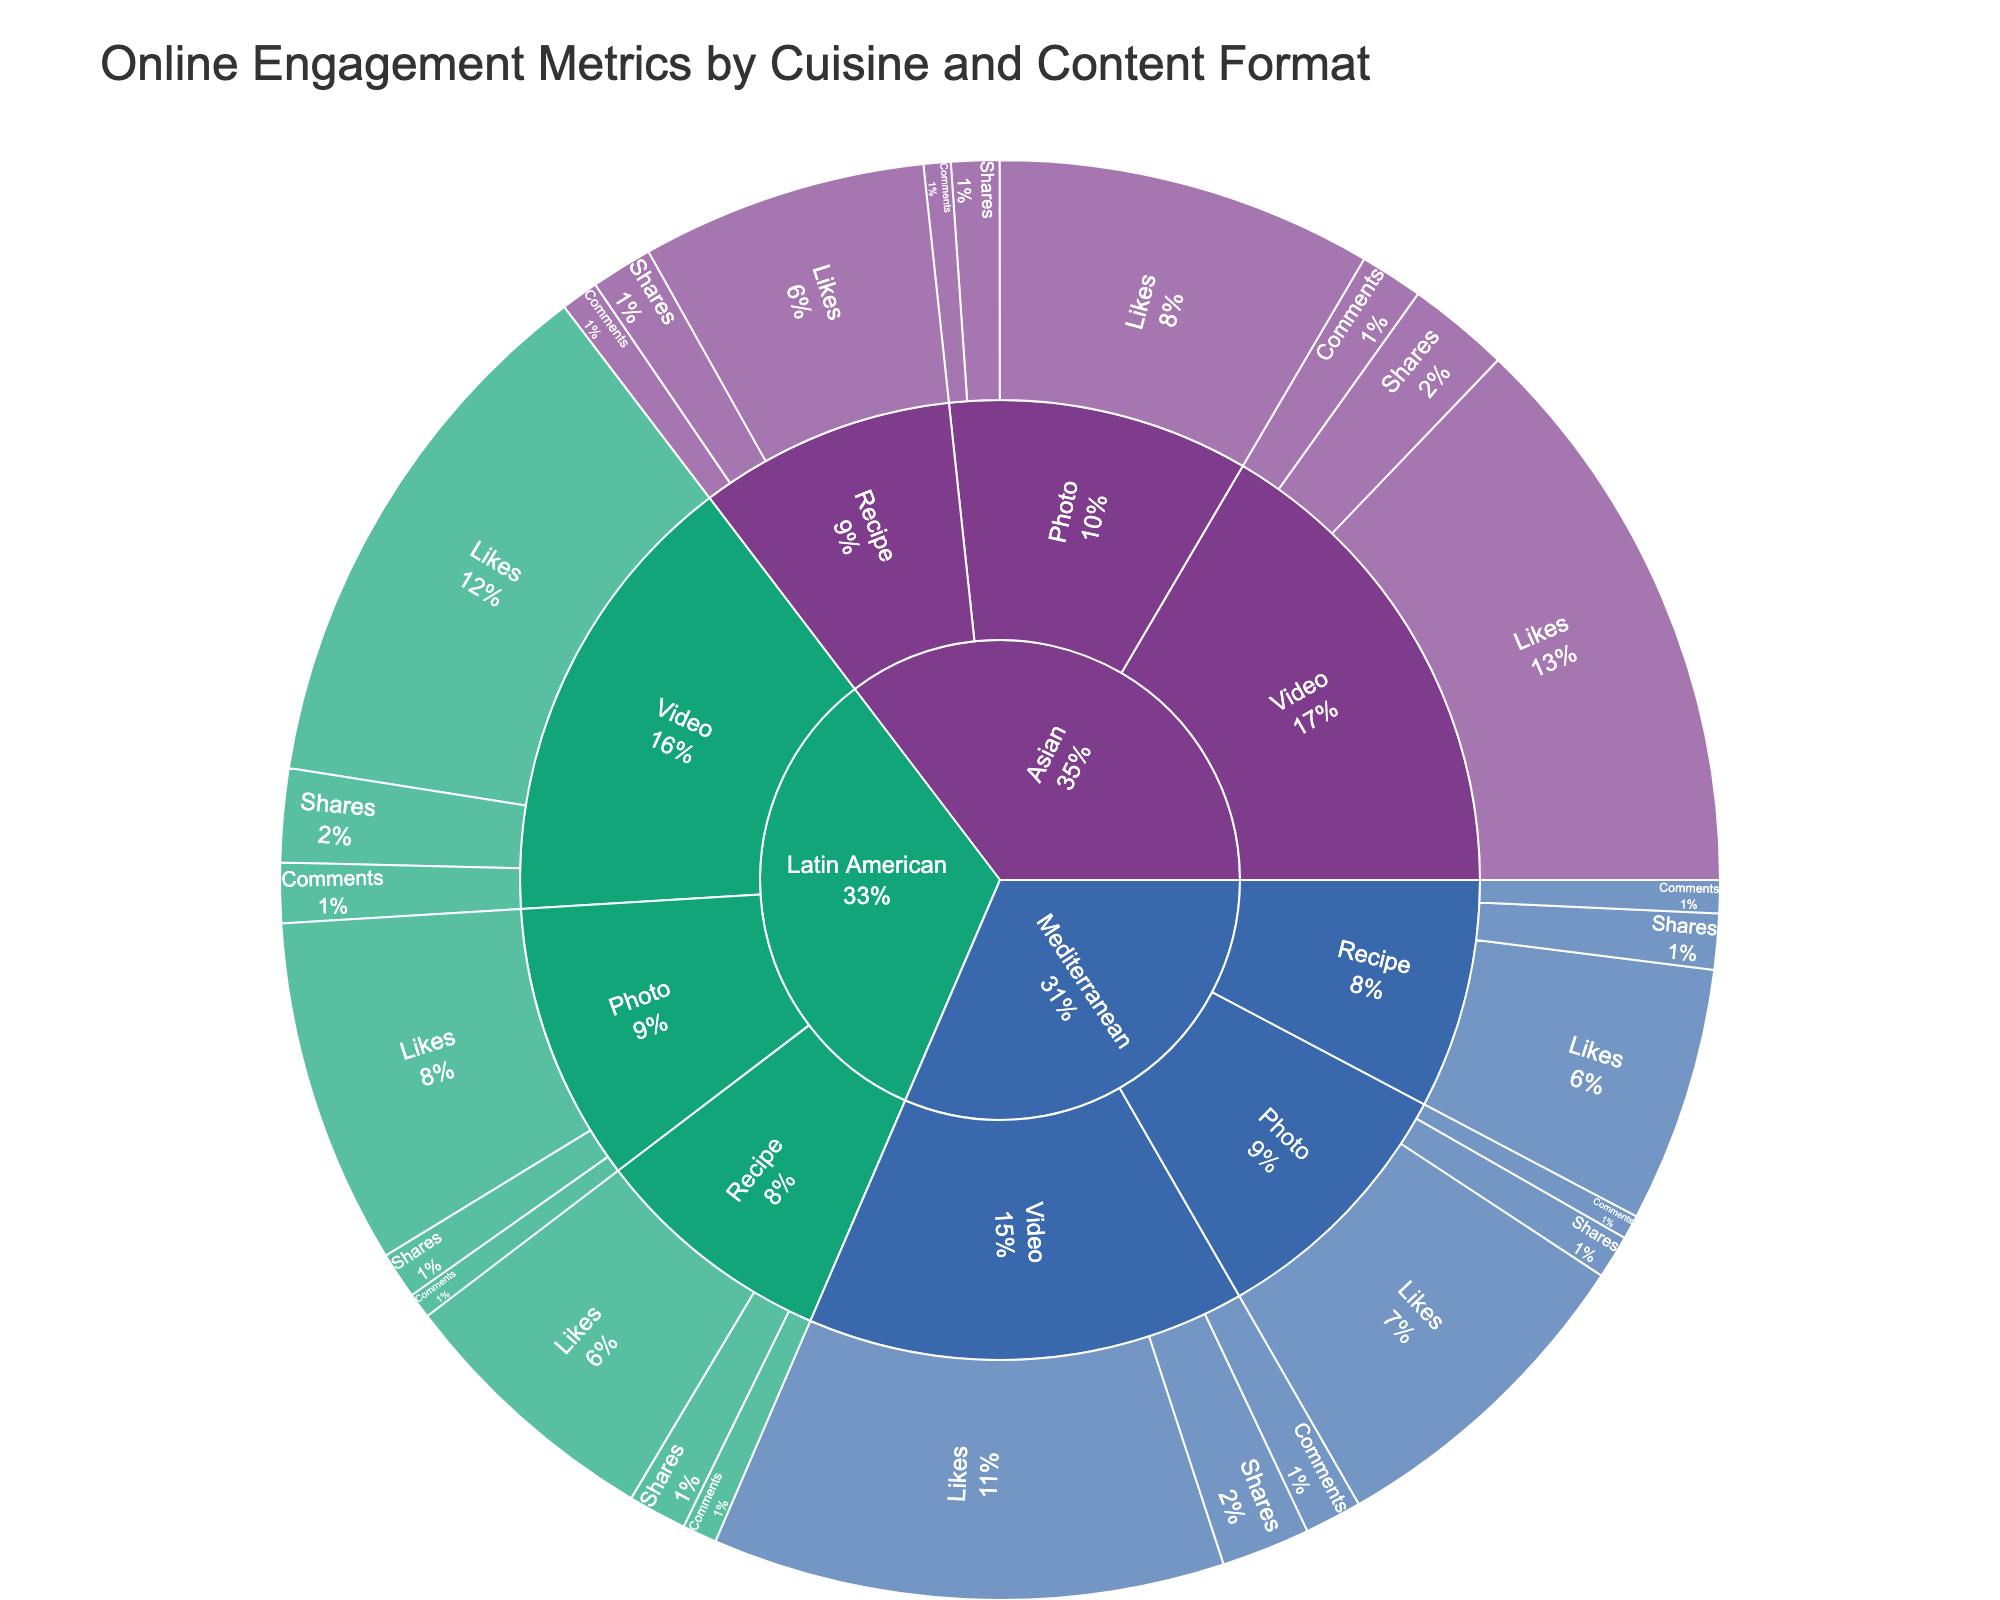What is the title of the sunburst plot? The title is usually displayed at the top of the plot. In the plot, it reads "Online Engagement Metrics by Cuisine and Content Format".
Answer: Online Engagement Metrics by Cuisine and Content Format Which cuisine type has the highest engagement metric value for videos? To find this, trace from the center to the cuisine segments, then look at the video segments and their respective engagement metrics. The cuisine type with the largest section for video engagement metric values is Asian for videos.
Answer: Asian How many likes did Mediterranean recipes receive? Navigate from the center to Mediterranean, then to recipes, and sum the 'likes' value for recipes. The value shown is 1700 likes.
Answer: 1700 What is the percentage contribution of comments for Latin American photos to the total engagement metrics for Latin American cuisine? First, sum all the values for Latin American engagement (2300+170+310 for photos; 3600+400+620 for videos; 1800+230+390 for recipes). Then, use the value for Latin American photo comments (170) and divide by the total, finally multiply by 100 for the percentage. Calculation: (170/(2300+170+310+3600+400+620+1800+230+390))*100 = 170/8820 * 100 ≈ 1.93%
Answer: 1.93% Which content format has the least comments across all cuisine types? Compare the size of the segments for comments within each content format (photos, videos, recipes). The smallest segments for comments are found in photos.
Answer: Photos Are there more likes for Latin American videos or Mediterranean videos? Check the 'likes' values for Latin American videos (3600) and Mediterranean videos (3400), and compare these values. The higher value is for Latin American videos.
Answer: Latin American videos What is the combined number of shares for all Asian content formats? Sum the 'shares' values for all Asian content formats: Photos (320), Videos (680), and Recipes (410). Calculation: 320 + 680 + 410 = 1410.
Answer: 1410 Which engagement metric has the highest value for Mediterranean recipes? Look at the segments for Mediterranean recipes and compare the values for likes, comments, and shares. The highest value is for likes (1700).
Answer: Likes What is the total number of comments across all content formats? Sum the 'comments' values for each content format and cuisine: 180+420+250+160+380+220+170+400+230. Total: 2410.
Answer: 2410 Which content format has the highest overall engagement among all cuisine types combined? Sum the engagement values for each content format (photos, videos, recipes) across all cuisine types. Compare the total sums. Videos have the highest overall engagement.
Answer: Videos How does the engagement metric for recipes compare between Asian and Latin American cuisines in terms of comments? Compare the 'comments' values for Asian recipes (250) and Latin American recipes (230). Asian recipes have more comments.
Answer: Asian recipes 